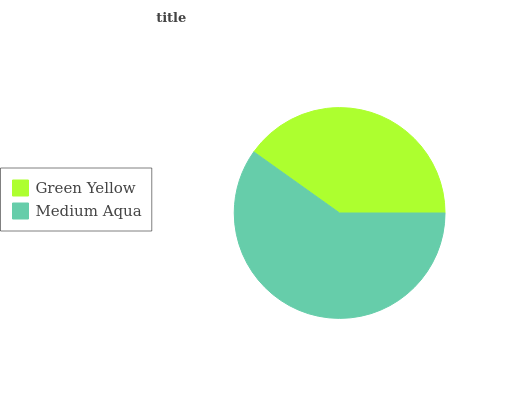Is Green Yellow the minimum?
Answer yes or no. Yes. Is Medium Aqua the maximum?
Answer yes or no. Yes. Is Medium Aqua the minimum?
Answer yes or no. No. Is Medium Aqua greater than Green Yellow?
Answer yes or no. Yes. Is Green Yellow less than Medium Aqua?
Answer yes or no. Yes. Is Green Yellow greater than Medium Aqua?
Answer yes or no. No. Is Medium Aqua less than Green Yellow?
Answer yes or no. No. Is Medium Aqua the high median?
Answer yes or no. Yes. Is Green Yellow the low median?
Answer yes or no. Yes. Is Green Yellow the high median?
Answer yes or no. No. Is Medium Aqua the low median?
Answer yes or no. No. 